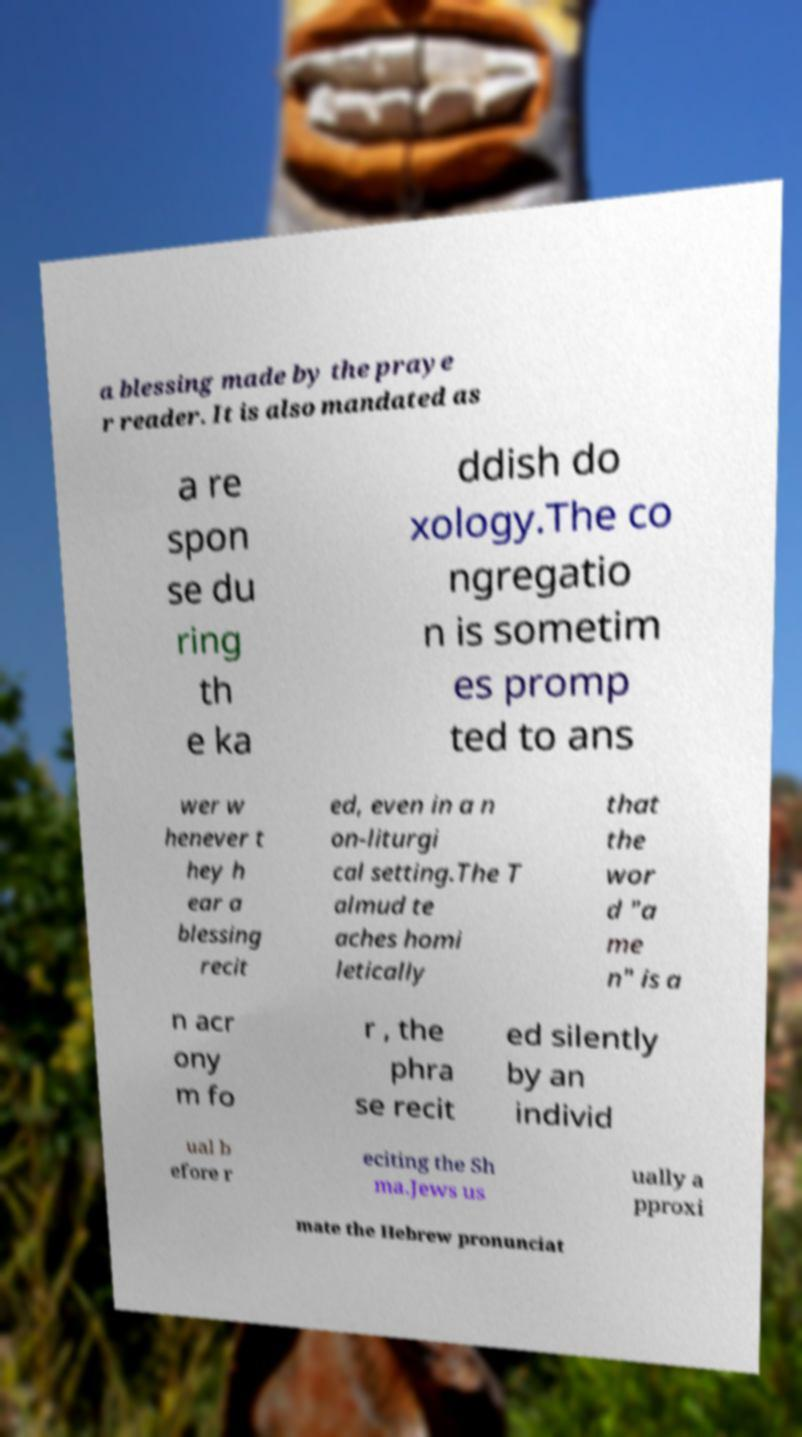Please identify and transcribe the text found in this image. a blessing made by the praye r reader. It is also mandated as a re spon se du ring th e ka ddish do xology.The co ngregatio n is sometim es promp ted to ans wer w henever t hey h ear a blessing recit ed, even in a n on-liturgi cal setting.The T almud te aches homi letically that the wor d "a me n" is a n acr ony m fo r , the phra se recit ed silently by an individ ual b efore r eciting the Sh ma.Jews us ually a pproxi mate the Hebrew pronunciat 